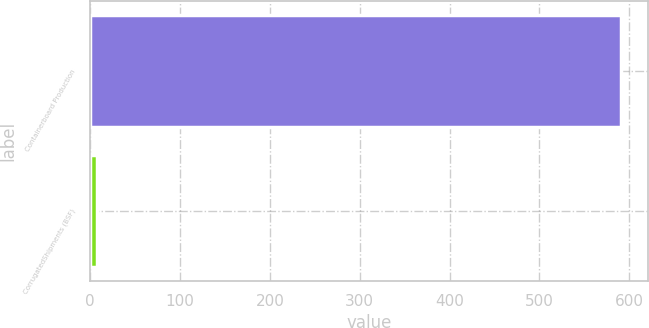Convert chart to OTSL. <chart><loc_0><loc_0><loc_500><loc_500><bar_chart><fcel>Containerboard Production<fcel>CorrugatedShipments (BSF)<nl><fcel>591<fcel>8<nl></chart> 